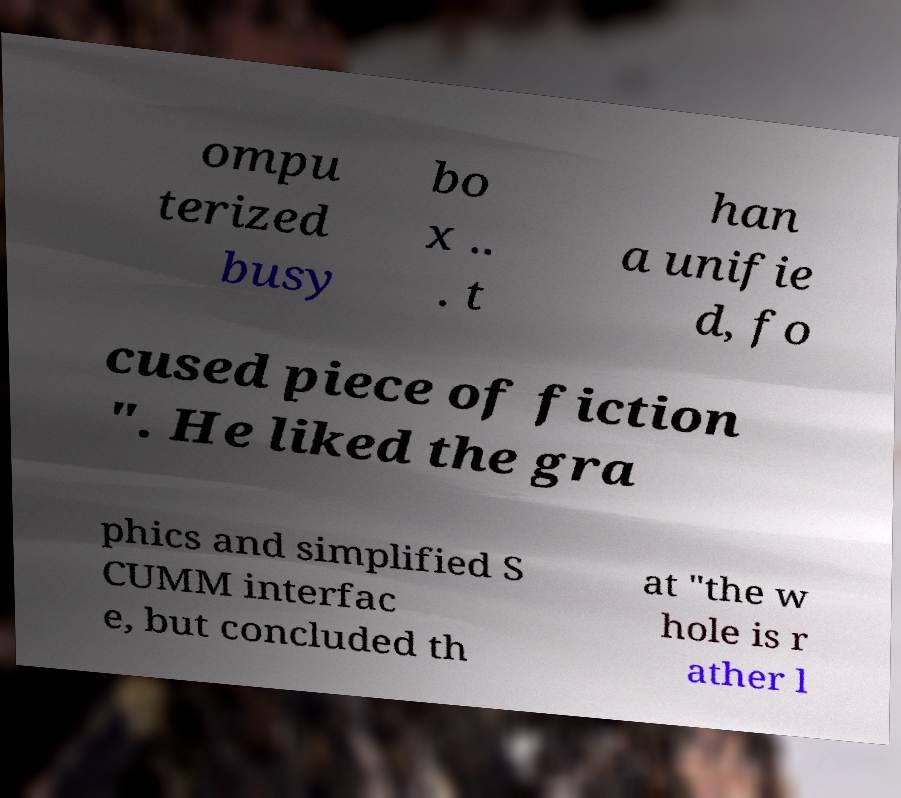Could you assist in decoding the text presented in this image and type it out clearly? ompu terized busy bo x .. . t han a unifie d, fo cused piece of fiction ". He liked the gra phics and simplified S CUMM interfac e, but concluded th at "the w hole is r ather l 